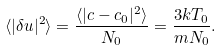Convert formula to latex. <formula><loc_0><loc_0><loc_500><loc_500>\langle | \delta u | ^ { 2 } \rangle = \frac { \langle | c - c _ { 0 } | ^ { 2 } \rangle } { N _ { 0 } } = \frac { 3 k T _ { 0 } } { m N _ { 0 } } .</formula> 